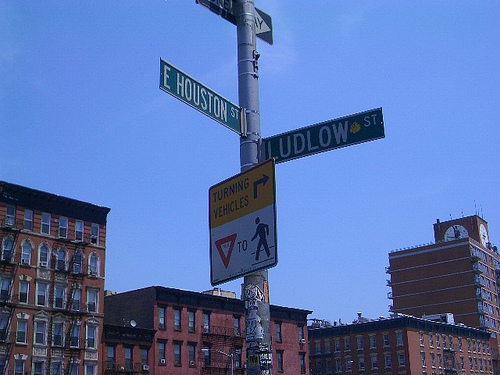Please extract the text content from this image. LDLOW ST VEHICLES TURNING TO Y ST HOUSTON E 